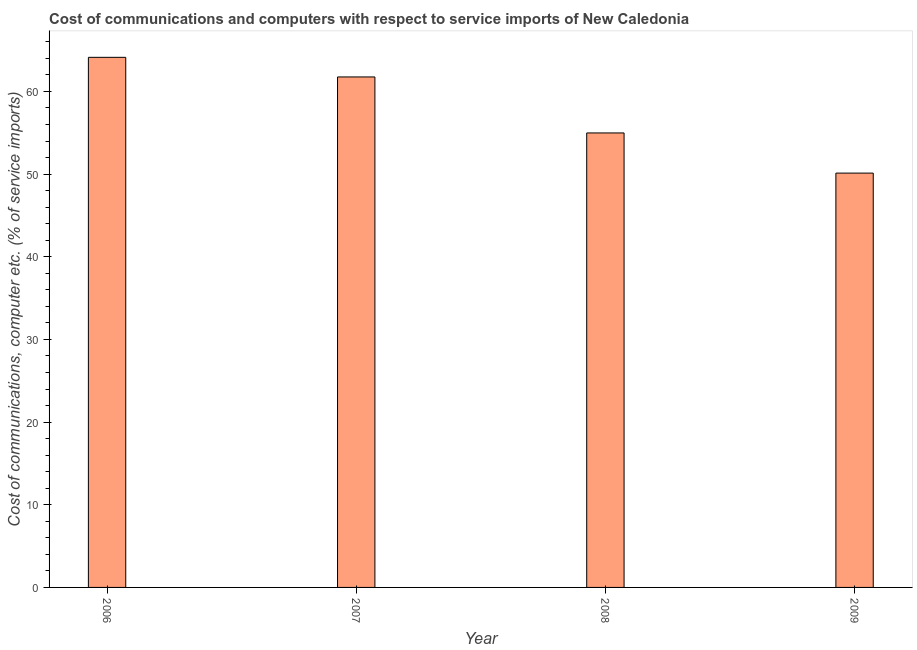Does the graph contain grids?
Keep it short and to the point. No. What is the title of the graph?
Your response must be concise. Cost of communications and computers with respect to service imports of New Caledonia. What is the label or title of the Y-axis?
Your answer should be very brief. Cost of communications, computer etc. (% of service imports). What is the cost of communications and computer in 2009?
Offer a terse response. 50.12. Across all years, what is the maximum cost of communications and computer?
Provide a succinct answer. 64.12. Across all years, what is the minimum cost of communications and computer?
Offer a terse response. 50.12. In which year was the cost of communications and computer maximum?
Make the answer very short. 2006. What is the sum of the cost of communications and computer?
Offer a very short reply. 230.97. What is the difference between the cost of communications and computer in 2006 and 2009?
Your response must be concise. 14. What is the average cost of communications and computer per year?
Your answer should be compact. 57.74. What is the median cost of communications and computer?
Provide a succinct answer. 58.36. In how many years, is the cost of communications and computer greater than 20 %?
Give a very brief answer. 4. Do a majority of the years between 2008 and 2009 (inclusive) have cost of communications and computer greater than 56 %?
Provide a short and direct response. No. What is the ratio of the cost of communications and computer in 2006 to that in 2009?
Offer a very short reply. 1.28. Is the cost of communications and computer in 2007 less than that in 2009?
Keep it short and to the point. No. Is the difference between the cost of communications and computer in 2007 and 2008 greater than the difference between any two years?
Provide a succinct answer. No. What is the difference between the highest and the second highest cost of communications and computer?
Give a very brief answer. 2.37. Is the sum of the cost of communications and computer in 2006 and 2009 greater than the maximum cost of communications and computer across all years?
Keep it short and to the point. Yes. What is the difference between the highest and the lowest cost of communications and computer?
Make the answer very short. 14. In how many years, is the cost of communications and computer greater than the average cost of communications and computer taken over all years?
Offer a very short reply. 2. How many years are there in the graph?
Keep it short and to the point. 4. Are the values on the major ticks of Y-axis written in scientific E-notation?
Your response must be concise. No. What is the Cost of communications, computer etc. (% of service imports) in 2006?
Your answer should be very brief. 64.12. What is the Cost of communications, computer etc. (% of service imports) of 2007?
Your answer should be compact. 61.75. What is the Cost of communications, computer etc. (% of service imports) in 2008?
Offer a very short reply. 54.98. What is the Cost of communications, computer etc. (% of service imports) in 2009?
Your response must be concise. 50.12. What is the difference between the Cost of communications, computer etc. (% of service imports) in 2006 and 2007?
Keep it short and to the point. 2.37. What is the difference between the Cost of communications, computer etc. (% of service imports) in 2006 and 2008?
Provide a succinct answer. 9.15. What is the difference between the Cost of communications, computer etc. (% of service imports) in 2006 and 2009?
Offer a very short reply. 14. What is the difference between the Cost of communications, computer etc. (% of service imports) in 2007 and 2008?
Give a very brief answer. 6.77. What is the difference between the Cost of communications, computer etc. (% of service imports) in 2007 and 2009?
Your answer should be very brief. 11.63. What is the difference between the Cost of communications, computer etc. (% of service imports) in 2008 and 2009?
Provide a succinct answer. 4.86. What is the ratio of the Cost of communications, computer etc. (% of service imports) in 2006 to that in 2007?
Your response must be concise. 1.04. What is the ratio of the Cost of communications, computer etc. (% of service imports) in 2006 to that in 2008?
Offer a very short reply. 1.17. What is the ratio of the Cost of communications, computer etc. (% of service imports) in 2006 to that in 2009?
Provide a succinct answer. 1.28. What is the ratio of the Cost of communications, computer etc. (% of service imports) in 2007 to that in 2008?
Offer a very short reply. 1.12. What is the ratio of the Cost of communications, computer etc. (% of service imports) in 2007 to that in 2009?
Provide a succinct answer. 1.23. What is the ratio of the Cost of communications, computer etc. (% of service imports) in 2008 to that in 2009?
Your response must be concise. 1.1. 